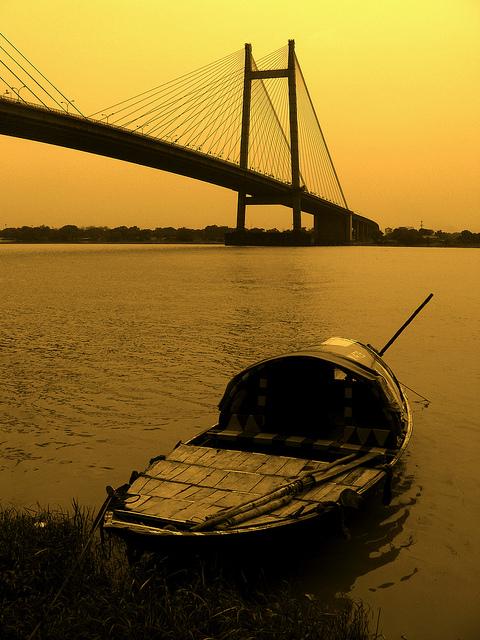What time of day is this?
Be succinct. Evening. Is that a boat?
Short answer required. Yes. Is this the Golden Gate bridge?
Quick response, please. Yes. 